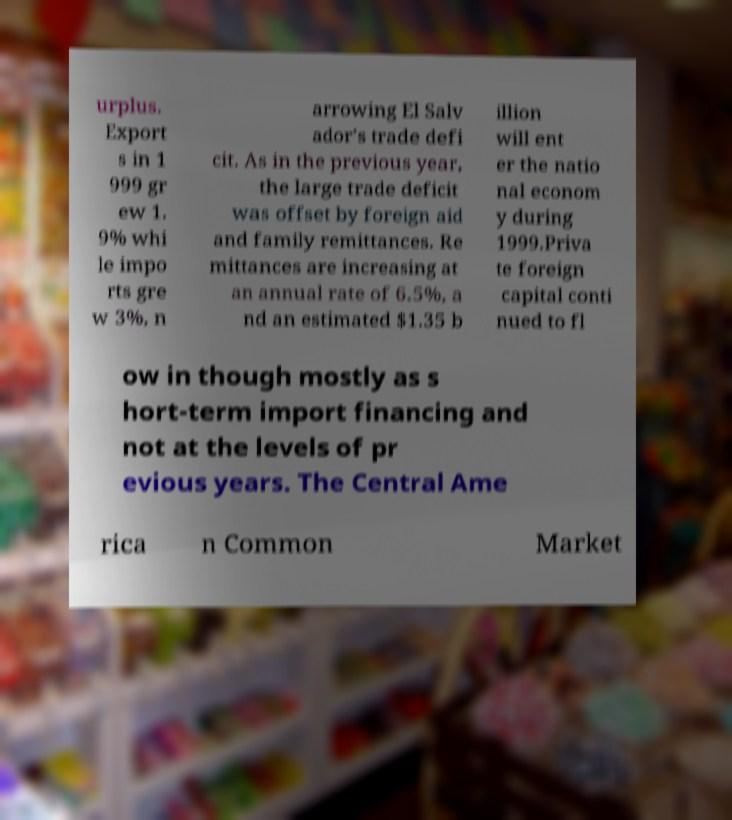For documentation purposes, I need the text within this image transcribed. Could you provide that? urplus. Export s in 1 999 gr ew 1. 9% whi le impo rts gre w 3%, n arrowing El Salv ador's trade defi cit. As in the previous year, the large trade deficit was offset by foreign aid and family remittances. Re mittances are increasing at an annual rate of 6.5%, a nd an estimated $1.35 b illion will ent er the natio nal econom y during 1999.Priva te foreign capital conti nued to fl ow in though mostly as s hort-term import financing and not at the levels of pr evious years. The Central Ame rica n Common Market 